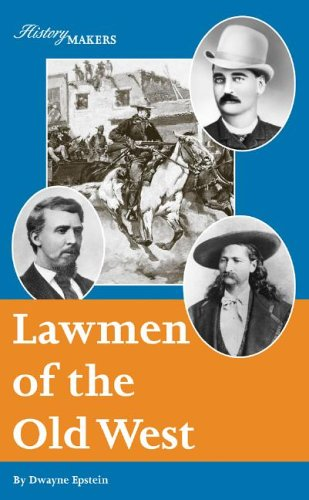Who wrote this book?
Answer the question using a single word or phrase. Dwayne Epstein What is the title of this book? Lawmen of the Old West (History Makers) What type of book is this? Teen & Young Adult Is this a youngster related book? Yes Is this a sci-fi book? No 